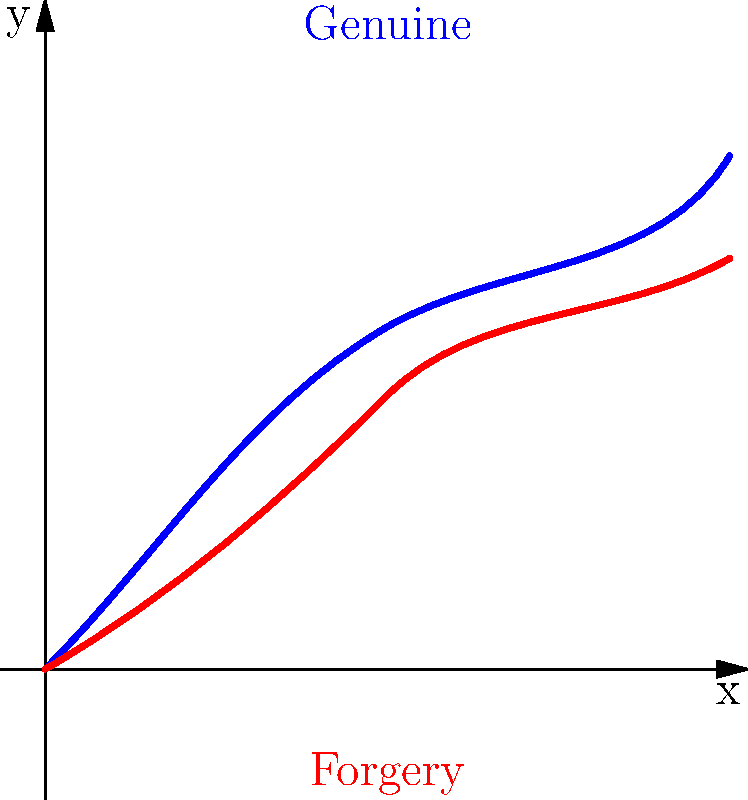In the magnified image above, two brush stroke patterns are shown: one representing a genuine artwork (blue) and one representing a forgery (red). Which characteristic of the genuine brush stroke pattern distinguishes it from the forgery? To analyze the brush stroke patterns and determine the distinguishing characteristic of the genuine artwork:

1. Observe the overall shape of both patterns:
   - The genuine (blue) stroke has a more pronounced curve.
   - The forgery (red) stroke is relatively flatter.

2. Analyze the starting points:
   - Both strokes begin at the origin (0,0).

3. Examine the initial direction:
   - The genuine stroke starts at a steeper angle (closer to 45°).
   - The forgery stroke starts at a shallower angle (closer to 30°).

4. Study the mid-section of the strokes:
   - The genuine stroke has a more pronounced dip in the middle.
   - The forgery stroke is more linear in the middle section.

5. Compare the endpoints:
   - The genuine stroke ends at a higher y-value.
   - The forgery stroke ends at a lower y-value.

6. Assess the overall fluidity:
   - The genuine stroke appears more fluid and natural.
   - The forgery stroke seems more controlled and less spontaneous.

The key distinguishing characteristic is the more pronounced curve and fluidity of the genuine brush stroke, which indicates a more natural and spontaneous application of paint typical of an experienced artist.
Answer: More pronounced curve and fluidity 